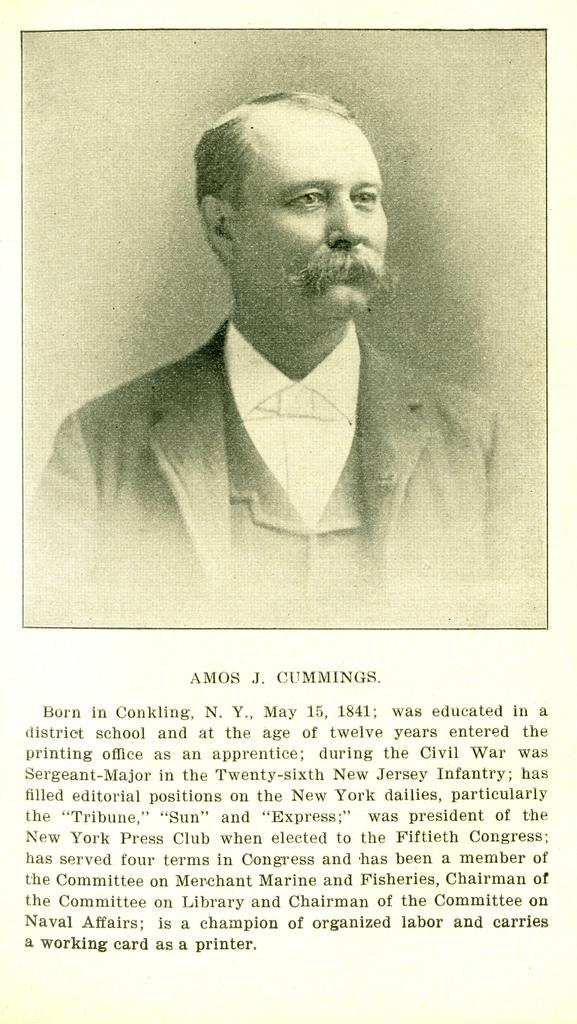What is the main subject of the image? There is a photograph of a man in the image. What direction is the man looking in? The man is looking to the right. What can be seen in the background of the image? There is a wall in the image. What is written at the bottom of the image? There is text written at the bottom of the image. What type of coal is being used to dig a hole in the image? There is no coal or digging activity present in the image. How many forks can be seen in the image? There are no forks present in the image. 